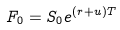<formula> <loc_0><loc_0><loc_500><loc_500>F _ { 0 } = S _ { 0 } e ^ { ( r + u ) T }</formula> 